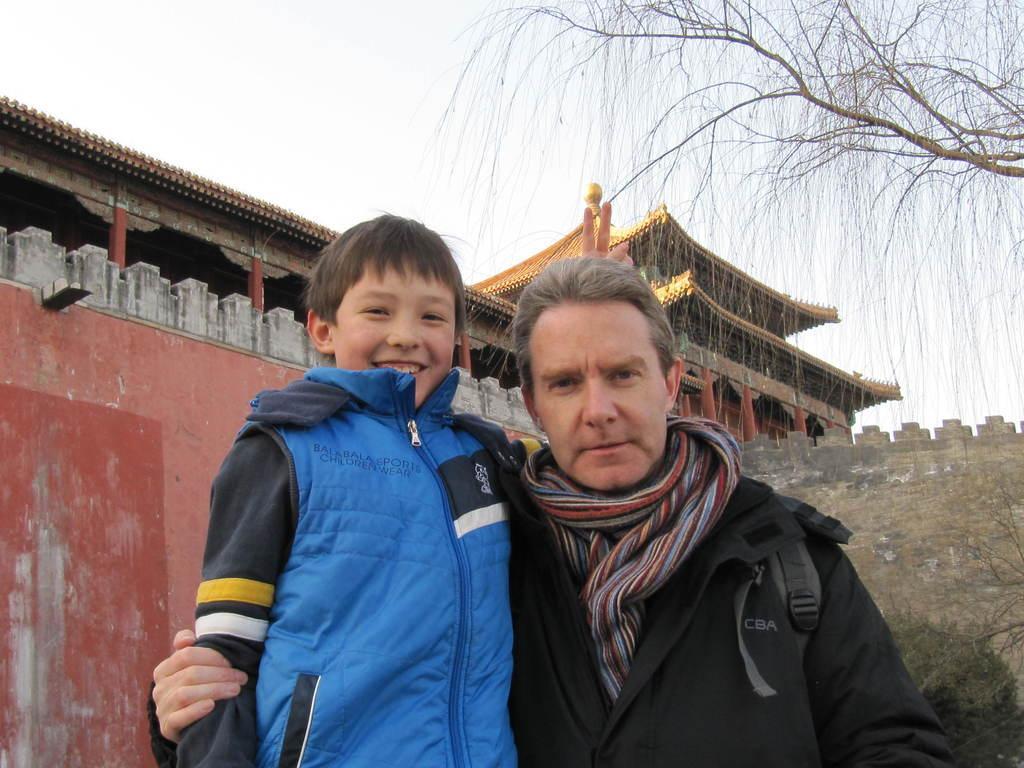Describe this image in one or two sentences. In the image two persons are standing and smiling. Behind them there are some buildings and trees. At the top of the image there is sky. 